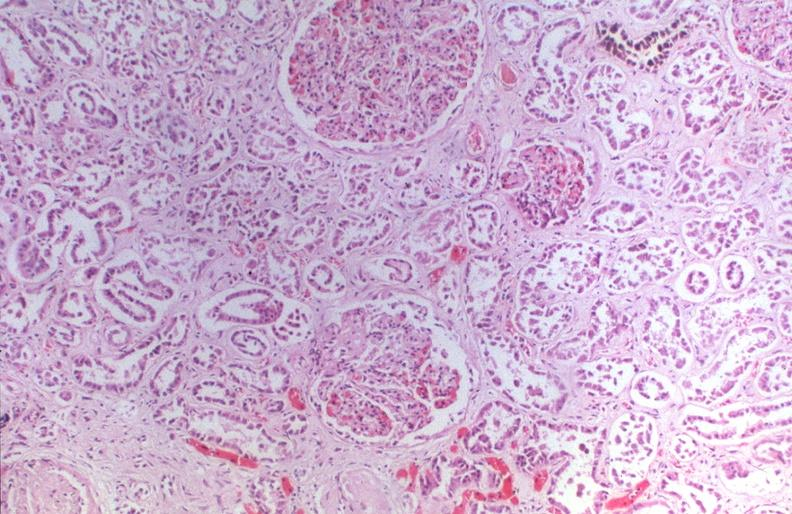does urinary show kidney, hemochromatosis?
Answer the question using a single word or phrase. No 